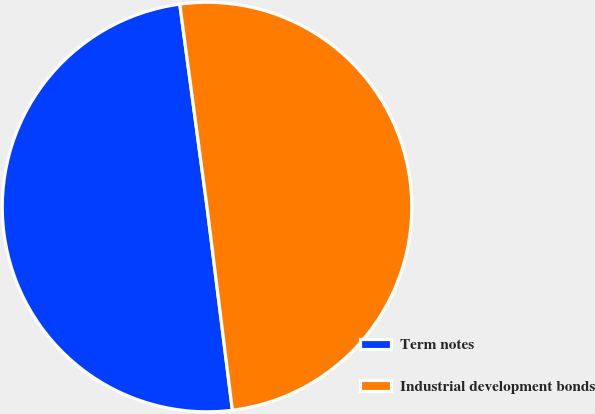Convert chart to OTSL. <chart><loc_0><loc_0><loc_500><loc_500><pie_chart><fcel>Term notes<fcel>Industrial development bonds<nl><fcel>49.85%<fcel>50.15%<nl></chart> 